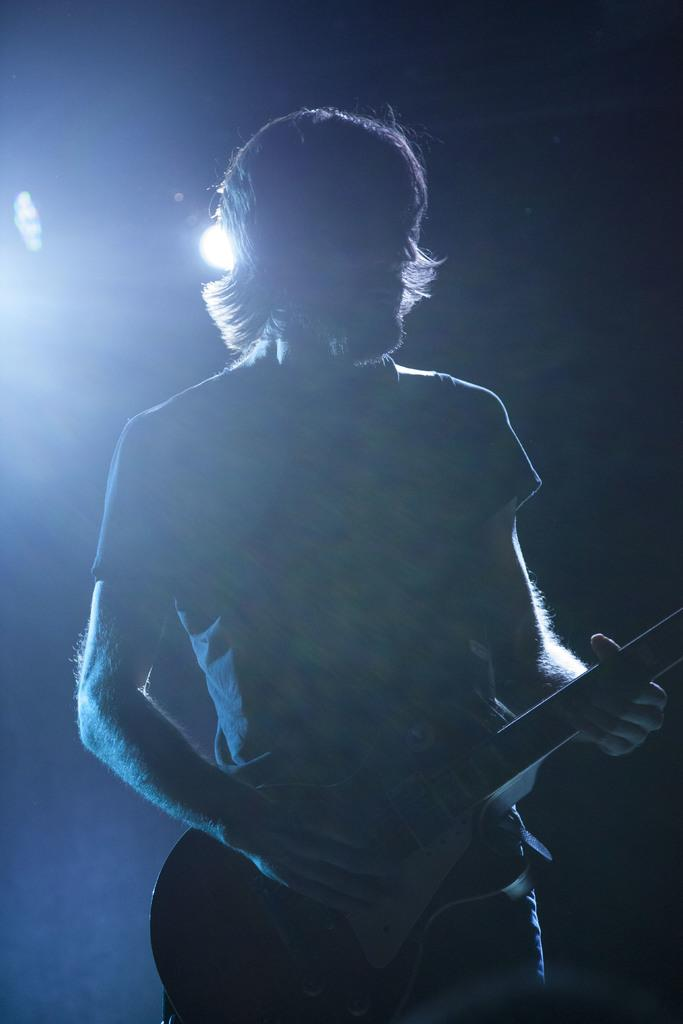What is the main subject of the image? There is a person in the image. What is the person doing in the image? The person is standing and holding a guitar in his hand. Can you describe the background of the image? There is a light in the background of the image. What type of magic is the person performing with the guitar in the image? There is no indication of magic or any magical performance in the image; the person is simply holding a guitar. 